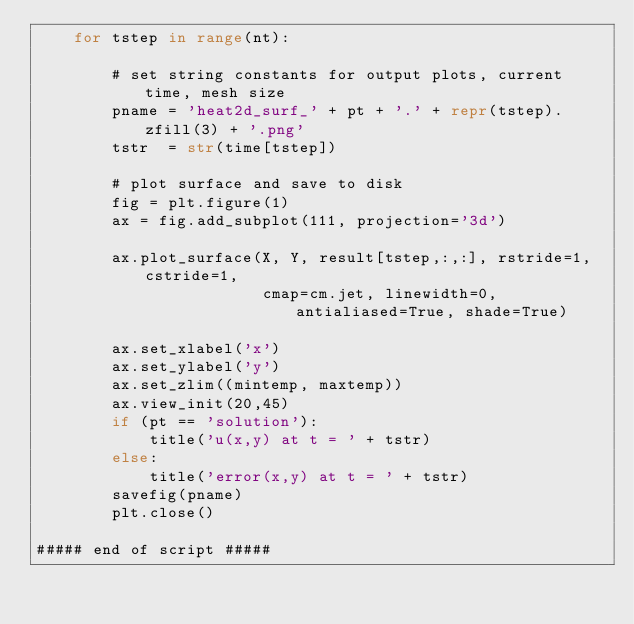Convert code to text. <code><loc_0><loc_0><loc_500><loc_500><_Python_>    for tstep in range(nt):

        # set string constants for output plots, current time, mesh size
        pname = 'heat2d_surf_' + pt + '.' + repr(tstep).zfill(3) + '.png'
        tstr  = str(time[tstep])

        # plot surface and save to disk
        fig = plt.figure(1)
        ax = fig.add_subplot(111, projection='3d')

        ax.plot_surface(X, Y, result[tstep,:,:], rstride=1, cstride=1,
                        cmap=cm.jet, linewidth=0, antialiased=True, shade=True)

        ax.set_xlabel('x')
        ax.set_ylabel('y')
        ax.set_zlim((mintemp, maxtemp))
        ax.view_init(20,45)
        if (pt == 'solution'):
            title('u(x,y) at t = ' + tstr)
        else:
            title('error(x,y) at t = ' + tstr)
        savefig(pname)
        plt.close()

##### end of script #####
</code> 